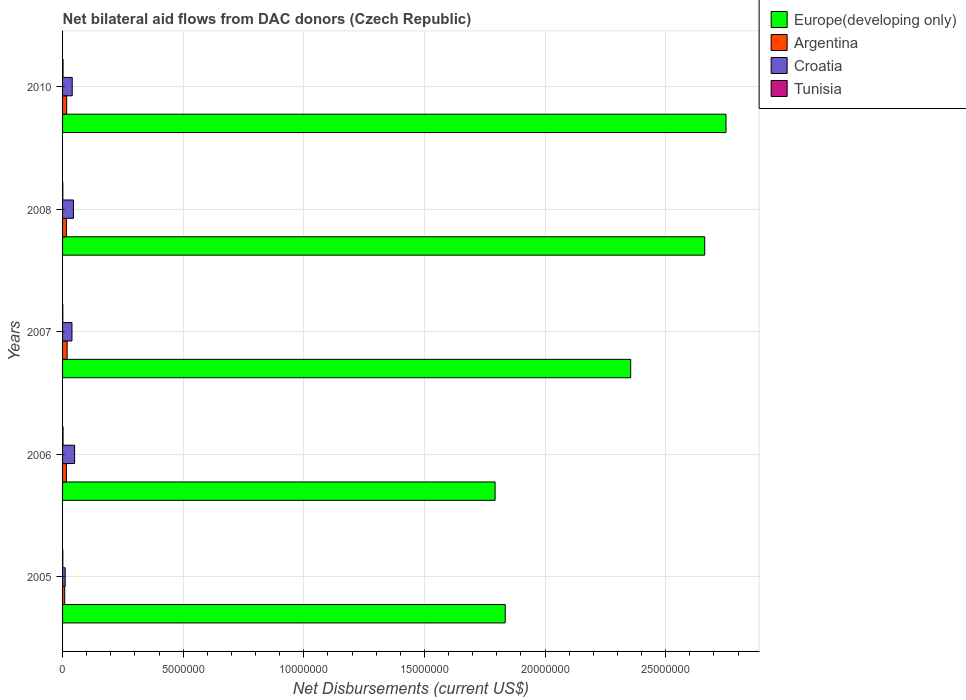How many groups of bars are there?
Your answer should be very brief. 5. Are the number of bars per tick equal to the number of legend labels?
Provide a succinct answer. Yes. Are the number of bars on each tick of the Y-axis equal?
Give a very brief answer. Yes. How many bars are there on the 4th tick from the top?
Offer a very short reply. 4. What is the label of the 1st group of bars from the top?
Keep it short and to the point. 2010. What is the net bilateral aid flows in Europe(developing only) in 2006?
Your answer should be very brief. 1.79e+07. Across all years, what is the maximum net bilateral aid flows in Europe(developing only)?
Your answer should be very brief. 2.75e+07. Across all years, what is the minimum net bilateral aid flows in Europe(developing only)?
Provide a short and direct response. 1.79e+07. In which year was the net bilateral aid flows in Europe(developing only) maximum?
Offer a terse response. 2010. What is the total net bilateral aid flows in Argentina in the graph?
Make the answer very short. 7.70e+05. What is the difference between the net bilateral aid flows in Europe(developing only) in 2006 and that in 2010?
Make the answer very short. -9.57e+06. What is the average net bilateral aid flows in Argentina per year?
Offer a terse response. 1.54e+05. In the year 2010, what is the difference between the net bilateral aid flows in Europe(developing only) and net bilateral aid flows in Tunisia?
Your response must be concise. 2.75e+07. What is the ratio of the net bilateral aid flows in Europe(developing only) in 2007 to that in 2008?
Give a very brief answer. 0.88. What is the difference between the highest and the second highest net bilateral aid flows in Croatia?
Your answer should be compact. 5.00e+04. What is the difference between the highest and the lowest net bilateral aid flows in Tunisia?
Offer a very short reply. 10000. In how many years, is the net bilateral aid flows in Europe(developing only) greater than the average net bilateral aid flows in Europe(developing only) taken over all years?
Your answer should be very brief. 3. Is the sum of the net bilateral aid flows in Argentina in 2005 and 2006 greater than the maximum net bilateral aid flows in Tunisia across all years?
Provide a succinct answer. Yes. What does the 1st bar from the bottom in 2010 represents?
Give a very brief answer. Europe(developing only). How many bars are there?
Your answer should be compact. 20. Are all the bars in the graph horizontal?
Make the answer very short. Yes. What is the difference between two consecutive major ticks on the X-axis?
Provide a succinct answer. 5.00e+06. Does the graph contain any zero values?
Your answer should be very brief. No. Does the graph contain grids?
Keep it short and to the point. Yes. Where does the legend appear in the graph?
Offer a very short reply. Top right. How many legend labels are there?
Keep it short and to the point. 4. What is the title of the graph?
Make the answer very short. Net bilateral aid flows from DAC donors (Czech Republic). What is the label or title of the X-axis?
Offer a terse response. Net Disbursements (current US$). What is the label or title of the Y-axis?
Provide a succinct answer. Years. What is the Net Disbursements (current US$) of Europe(developing only) in 2005?
Offer a terse response. 1.84e+07. What is the Net Disbursements (current US$) in Argentina in 2005?
Give a very brief answer. 9.00e+04. What is the Net Disbursements (current US$) of Tunisia in 2005?
Provide a short and direct response. 10000. What is the Net Disbursements (current US$) in Europe(developing only) in 2006?
Your answer should be compact. 1.79e+07. What is the Net Disbursements (current US$) of Tunisia in 2006?
Ensure brevity in your answer.  2.00e+04. What is the Net Disbursements (current US$) in Europe(developing only) in 2007?
Provide a succinct answer. 2.36e+07. What is the Net Disbursements (current US$) of Tunisia in 2007?
Provide a succinct answer. 10000. What is the Net Disbursements (current US$) of Europe(developing only) in 2008?
Your response must be concise. 2.66e+07. What is the Net Disbursements (current US$) of Croatia in 2008?
Your response must be concise. 4.50e+05. What is the Net Disbursements (current US$) of Tunisia in 2008?
Ensure brevity in your answer.  10000. What is the Net Disbursements (current US$) in Europe(developing only) in 2010?
Offer a very short reply. 2.75e+07. What is the Net Disbursements (current US$) in Tunisia in 2010?
Give a very brief answer. 2.00e+04. Across all years, what is the maximum Net Disbursements (current US$) in Europe(developing only)?
Your answer should be compact. 2.75e+07. Across all years, what is the maximum Net Disbursements (current US$) of Argentina?
Offer a very short reply. 1.90e+05. Across all years, what is the minimum Net Disbursements (current US$) in Europe(developing only)?
Offer a terse response. 1.79e+07. Across all years, what is the minimum Net Disbursements (current US$) of Croatia?
Provide a short and direct response. 1.10e+05. Across all years, what is the minimum Net Disbursements (current US$) in Tunisia?
Give a very brief answer. 10000. What is the total Net Disbursements (current US$) of Europe(developing only) in the graph?
Your answer should be very brief. 1.14e+08. What is the total Net Disbursements (current US$) of Argentina in the graph?
Offer a very short reply. 7.70e+05. What is the total Net Disbursements (current US$) of Croatia in the graph?
Provide a succinct answer. 1.85e+06. What is the total Net Disbursements (current US$) of Tunisia in the graph?
Ensure brevity in your answer.  7.00e+04. What is the difference between the Net Disbursements (current US$) in Croatia in 2005 and that in 2006?
Keep it short and to the point. -3.90e+05. What is the difference between the Net Disbursements (current US$) in Tunisia in 2005 and that in 2006?
Provide a short and direct response. -10000. What is the difference between the Net Disbursements (current US$) in Europe(developing only) in 2005 and that in 2007?
Offer a very short reply. -5.20e+06. What is the difference between the Net Disbursements (current US$) of Argentina in 2005 and that in 2007?
Give a very brief answer. -1.00e+05. What is the difference between the Net Disbursements (current US$) of Croatia in 2005 and that in 2007?
Offer a very short reply. -2.80e+05. What is the difference between the Net Disbursements (current US$) of Tunisia in 2005 and that in 2007?
Provide a short and direct response. 0. What is the difference between the Net Disbursements (current US$) in Europe(developing only) in 2005 and that in 2008?
Give a very brief answer. -8.27e+06. What is the difference between the Net Disbursements (current US$) of Europe(developing only) in 2005 and that in 2010?
Offer a very short reply. -9.15e+06. What is the difference between the Net Disbursements (current US$) of Argentina in 2005 and that in 2010?
Give a very brief answer. -8.00e+04. What is the difference between the Net Disbursements (current US$) of Tunisia in 2005 and that in 2010?
Offer a terse response. -10000. What is the difference between the Net Disbursements (current US$) in Europe(developing only) in 2006 and that in 2007?
Give a very brief answer. -5.62e+06. What is the difference between the Net Disbursements (current US$) of Europe(developing only) in 2006 and that in 2008?
Provide a succinct answer. -8.69e+06. What is the difference between the Net Disbursements (current US$) in Argentina in 2006 and that in 2008?
Offer a very short reply. 0. What is the difference between the Net Disbursements (current US$) in Croatia in 2006 and that in 2008?
Your answer should be very brief. 5.00e+04. What is the difference between the Net Disbursements (current US$) in Tunisia in 2006 and that in 2008?
Make the answer very short. 10000. What is the difference between the Net Disbursements (current US$) in Europe(developing only) in 2006 and that in 2010?
Make the answer very short. -9.57e+06. What is the difference between the Net Disbursements (current US$) in Croatia in 2006 and that in 2010?
Provide a short and direct response. 1.00e+05. What is the difference between the Net Disbursements (current US$) in Tunisia in 2006 and that in 2010?
Offer a very short reply. 0. What is the difference between the Net Disbursements (current US$) of Europe(developing only) in 2007 and that in 2008?
Offer a terse response. -3.07e+06. What is the difference between the Net Disbursements (current US$) of Croatia in 2007 and that in 2008?
Ensure brevity in your answer.  -6.00e+04. What is the difference between the Net Disbursements (current US$) of Europe(developing only) in 2007 and that in 2010?
Make the answer very short. -3.95e+06. What is the difference between the Net Disbursements (current US$) of Croatia in 2007 and that in 2010?
Keep it short and to the point. -10000. What is the difference between the Net Disbursements (current US$) in Tunisia in 2007 and that in 2010?
Make the answer very short. -10000. What is the difference between the Net Disbursements (current US$) of Europe(developing only) in 2008 and that in 2010?
Make the answer very short. -8.80e+05. What is the difference between the Net Disbursements (current US$) of Argentina in 2008 and that in 2010?
Provide a short and direct response. -10000. What is the difference between the Net Disbursements (current US$) in Europe(developing only) in 2005 and the Net Disbursements (current US$) in Argentina in 2006?
Offer a very short reply. 1.82e+07. What is the difference between the Net Disbursements (current US$) in Europe(developing only) in 2005 and the Net Disbursements (current US$) in Croatia in 2006?
Your answer should be compact. 1.78e+07. What is the difference between the Net Disbursements (current US$) of Europe(developing only) in 2005 and the Net Disbursements (current US$) of Tunisia in 2006?
Make the answer very short. 1.83e+07. What is the difference between the Net Disbursements (current US$) in Argentina in 2005 and the Net Disbursements (current US$) in Croatia in 2006?
Provide a succinct answer. -4.10e+05. What is the difference between the Net Disbursements (current US$) of Argentina in 2005 and the Net Disbursements (current US$) of Tunisia in 2006?
Your response must be concise. 7.00e+04. What is the difference between the Net Disbursements (current US$) in Croatia in 2005 and the Net Disbursements (current US$) in Tunisia in 2006?
Your answer should be very brief. 9.00e+04. What is the difference between the Net Disbursements (current US$) in Europe(developing only) in 2005 and the Net Disbursements (current US$) in Argentina in 2007?
Your answer should be very brief. 1.82e+07. What is the difference between the Net Disbursements (current US$) of Europe(developing only) in 2005 and the Net Disbursements (current US$) of Croatia in 2007?
Offer a terse response. 1.80e+07. What is the difference between the Net Disbursements (current US$) of Europe(developing only) in 2005 and the Net Disbursements (current US$) of Tunisia in 2007?
Ensure brevity in your answer.  1.83e+07. What is the difference between the Net Disbursements (current US$) of Argentina in 2005 and the Net Disbursements (current US$) of Tunisia in 2007?
Ensure brevity in your answer.  8.00e+04. What is the difference between the Net Disbursements (current US$) of Europe(developing only) in 2005 and the Net Disbursements (current US$) of Argentina in 2008?
Offer a terse response. 1.82e+07. What is the difference between the Net Disbursements (current US$) in Europe(developing only) in 2005 and the Net Disbursements (current US$) in Croatia in 2008?
Your answer should be very brief. 1.79e+07. What is the difference between the Net Disbursements (current US$) in Europe(developing only) in 2005 and the Net Disbursements (current US$) in Tunisia in 2008?
Provide a succinct answer. 1.83e+07. What is the difference between the Net Disbursements (current US$) in Argentina in 2005 and the Net Disbursements (current US$) in Croatia in 2008?
Provide a succinct answer. -3.60e+05. What is the difference between the Net Disbursements (current US$) in Argentina in 2005 and the Net Disbursements (current US$) in Tunisia in 2008?
Offer a very short reply. 8.00e+04. What is the difference between the Net Disbursements (current US$) in Europe(developing only) in 2005 and the Net Disbursements (current US$) in Argentina in 2010?
Keep it short and to the point. 1.82e+07. What is the difference between the Net Disbursements (current US$) in Europe(developing only) in 2005 and the Net Disbursements (current US$) in Croatia in 2010?
Make the answer very short. 1.80e+07. What is the difference between the Net Disbursements (current US$) in Europe(developing only) in 2005 and the Net Disbursements (current US$) in Tunisia in 2010?
Provide a short and direct response. 1.83e+07. What is the difference between the Net Disbursements (current US$) in Argentina in 2005 and the Net Disbursements (current US$) in Croatia in 2010?
Offer a very short reply. -3.10e+05. What is the difference between the Net Disbursements (current US$) in Argentina in 2005 and the Net Disbursements (current US$) in Tunisia in 2010?
Your response must be concise. 7.00e+04. What is the difference between the Net Disbursements (current US$) in Croatia in 2005 and the Net Disbursements (current US$) in Tunisia in 2010?
Give a very brief answer. 9.00e+04. What is the difference between the Net Disbursements (current US$) in Europe(developing only) in 2006 and the Net Disbursements (current US$) in Argentina in 2007?
Ensure brevity in your answer.  1.77e+07. What is the difference between the Net Disbursements (current US$) in Europe(developing only) in 2006 and the Net Disbursements (current US$) in Croatia in 2007?
Your answer should be compact. 1.75e+07. What is the difference between the Net Disbursements (current US$) in Europe(developing only) in 2006 and the Net Disbursements (current US$) in Tunisia in 2007?
Give a very brief answer. 1.79e+07. What is the difference between the Net Disbursements (current US$) in Croatia in 2006 and the Net Disbursements (current US$) in Tunisia in 2007?
Your answer should be compact. 4.90e+05. What is the difference between the Net Disbursements (current US$) in Europe(developing only) in 2006 and the Net Disbursements (current US$) in Argentina in 2008?
Your response must be concise. 1.78e+07. What is the difference between the Net Disbursements (current US$) of Europe(developing only) in 2006 and the Net Disbursements (current US$) of Croatia in 2008?
Ensure brevity in your answer.  1.75e+07. What is the difference between the Net Disbursements (current US$) in Europe(developing only) in 2006 and the Net Disbursements (current US$) in Tunisia in 2008?
Offer a terse response. 1.79e+07. What is the difference between the Net Disbursements (current US$) of Europe(developing only) in 2006 and the Net Disbursements (current US$) of Argentina in 2010?
Ensure brevity in your answer.  1.78e+07. What is the difference between the Net Disbursements (current US$) of Europe(developing only) in 2006 and the Net Disbursements (current US$) of Croatia in 2010?
Your answer should be compact. 1.75e+07. What is the difference between the Net Disbursements (current US$) in Europe(developing only) in 2006 and the Net Disbursements (current US$) in Tunisia in 2010?
Give a very brief answer. 1.79e+07. What is the difference between the Net Disbursements (current US$) in Argentina in 2006 and the Net Disbursements (current US$) in Croatia in 2010?
Your answer should be very brief. -2.40e+05. What is the difference between the Net Disbursements (current US$) of Argentina in 2006 and the Net Disbursements (current US$) of Tunisia in 2010?
Make the answer very short. 1.40e+05. What is the difference between the Net Disbursements (current US$) of Europe(developing only) in 2007 and the Net Disbursements (current US$) of Argentina in 2008?
Your answer should be compact. 2.34e+07. What is the difference between the Net Disbursements (current US$) of Europe(developing only) in 2007 and the Net Disbursements (current US$) of Croatia in 2008?
Give a very brief answer. 2.31e+07. What is the difference between the Net Disbursements (current US$) in Europe(developing only) in 2007 and the Net Disbursements (current US$) in Tunisia in 2008?
Make the answer very short. 2.35e+07. What is the difference between the Net Disbursements (current US$) of Croatia in 2007 and the Net Disbursements (current US$) of Tunisia in 2008?
Keep it short and to the point. 3.80e+05. What is the difference between the Net Disbursements (current US$) of Europe(developing only) in 2007 and the Net Disbursements (current US$) of Argentina in 2010?
Give a very brief answer. 2.34e+07. What is the difference between the Net Disbursements (current US$) of Europe(developing only) in 2007 and the Net Disbursements (current US$) of Croatia in 2010?
Provide a succinct answer. 2.32e+07. What is the difference between the Net Disbursements (current US$) of Europe(developing only) in 2007 and the Net Disbursements (current US$) of Tunisia in 2010?
Ensure brevity in your answer.  2.35e+07. What is the difference between the Net Disbursements (current US$) in Croatia in 2007 and the Net Disbursements (current US$) in Tunisia in 2010?
Offer a very short reply. 3.70e+05. What is the difference between the Net Disbursements (current US$) in Europe(developing only) in 2008 and the Net Disbursements (current US$) in Argentina in 2010?
Make the answer very short. 2.64e+07. What is the difference between the Net Disbursements (current US$) in Europe(developing only) in 2008 and the Net Disbursements (current US$) in Croatia in 2010?
Ensure brevity in your answer.  2.62e+07. What is the difference between the Net Disbursements (current US$) of Europe(developing only) in 2008 and the Net Disbursements (current US$) of Tunisia in 2010?
Provide a succinct answer. 2.66e+07. What is the average Net Disbursements (current US$) in Europe(developing only) per year?
Give a very brief answer. 2.28e+07. What is the average Net Disbursements (current US$) in Argentina per year?
Ensure brevity in your answer.  1.54e+05. What is the average Net Disbursements (current US$) of Tunisia per year?
Your response must be concise. 1.40e+04. In the year 2005, what is the difference between the Net Disbursements (current US$) in Europe(developing only) and Net Disbursements (current US$) in Argentina?
Your response must be concise. 1.83e+07. In the year 2005, what is the difference between the Net Disbursements (current US$) of Europe(developing only) and Net Disbursements (current US$) of Croatia?
Your response must be concise. 1.82e+07. In the year 2005, what is the difference between the Net Disbursements (current US$) of Europe(developing only) and Net Disbursements (current US$) of Tunisia?
Offer a very short reply. 1.83e+07. In the year 2005, what is the difference between the Net Disbursements (current US$) in Argentina and Net Disbursements (current US$) in Croatia?
Make the answer very short. -2.00e+04. In the year 2005, what is the difference between the Net Disbursements (current US$) in Croatia and Net Disbursements (current US$) in Tunisia?
Keep it short and to the point. 1.00e+05. In the year 2006, what is the difference between the Net Disbursements (current US$) in Europe(developing only) and Net Disbursements (current US$) in Argentina?
Your answer should be very brief. 1.78e+07. In the year 2006, what is the difference between the Net Disbursements (current US$) in Europe(developing only) and Net Disbursements (current US$) in Croatia?
Make the answer very short. 1.74e+07. In the year 2006, what is the difference between the Net Disbursements (current US$) in Europe(developing only) and Net Disbursements (current US$) in Tunisia?
Ensure brevity in your answer.  1.79e+07. In the year 2006, what is the difference between the Net Disbursements (current US$) in Argentina and Net Disbursements (current US$) in Croatia?
Your answer should be very brief. -3.40e+05. In the year 2006, what is the difference between the Net Disbursements (current US$) of Croatia and Net Disbursements (current US$) of Tunisia?
Make the answer very short. 4.80e+05. In the year 2007, what is the difference between the Net Disbursements (current US$) in Europe(developing only) and Net Disbursements (current US$) in Argentina?
Your response must be concise. 2.34e+07. In the year 2007, what is the difference between the Net Disbursements (current US$) of Europe(developing only) and Net Disbursements (current US$) of Croatia?
Make the answer very short. 2.32e+07. In the year 2007, what is the difference between the Net Disbursements (current US$) of Europe(developing only) and Net Disbursements (current US$) of Tunisia?
Provide a succinct answer. 2.35e+07. In the year 2008, what is the difference between the Net Disbursements (current US$) of Europe(developing only) and Net Disbursements (current US$) of Argentina?
Ensure brevity in your answer.  2.65e+07. In the year 2008, what is the difference between the Net Disbursements (current US$) of Europe(developing only) and Net Disbursements (current US$) of Croatia?
Your answer should be very brief. 2.62e+07. In the year 2008, what is the difference between the Net Disbursements (current US$) of Europe(developing only) and Net Disbursements (current US$) of Tunisia?
Give a very brief answer. 2.66e+07. In the year 2010, what is the difference between the Net Disbursements (current US$) of Europe(developing only) and Net Disbursements (current US$) of Argentina?
Your answer should be compact. 2.73e+07. In the year 2010, what is the difference between the Net Disbursements (current US$) of Europe(developing only) and Net Disbursements (current US$) of Croatia?
Your answer should be very brief. 2.71e+07. In the year 2010, what is the difference between the Net Disbursements (current US$) of Europe(developing only) and Net Disbursements (current US$) of Tunisia?
Offer a very short reply. 2.75e+07. In the year 2010, what is the difference between the Net Disbursements (current US$) in Argentina and Net Disbursements (current US$) in Croatia?
Offer a very short reply. -2.30e+05. In the year 2010, what is the difference between the Net Disbursements (current US$) of Argentina and Net Disbursements (current US$) of Tunisia?
Provide a succinct answer. 1.50e+05. What is the ratio of the Net Disbursements (current US$) in Europe(developing only) in 2005 to that in 2006?
Your answer should be compact. 1.02. What is the ratio of the Net Disbursements (current US$) of Argentina in 2005 to that in 2006?
Ensure brevity in your answer.  0.56. What is the ratio of the Net Disbursements (current US$) in Croatia in 2005 to that in 2006?
Your answer should be compact. 0.22. What is the ratio of the Net Disbursements (current US$) in Europe(developing only) in 2005 to that in 2007?
Your answer should be compact. 0.78. What is the ratio of the Net Disbursements (current US$) of Argentina in 2005 to that in 2007?
Give a very brief answer. 0.47. What is the ratio of the Net Disbursements (current US$) of Croatia in 2005 to that in 2007?
Your answer should be very brief. 0.28. What is the ratio of the Net Disbursements (current US$) in Europe(developing only) in 2005 to that in 2008?
Your response must be concise. 0.69. What is the ratio of the Net Disbursements (current US$) in Argentina in 2005 to that in 2008?
Offer a very short reply. 0.56. What is the ratio of the Net Disbursements (current US$) in Croatia in 2005 to that in 2008?
Your answer should be very brief. 0.24. What is the ratio of the Net Disbursements (current US$) of Tunisia in 2005 to that in 2008?
Keep it short and to the point. 1. What is the ratio of the Net Disbursements (current US$) in Europe(developing only) in 2005 to that in 2010?
Offer a terse response. 0.67. What is the ratio of the Net Disbursements (current US$) of Argentina in 2005 to that in 2010?
Give a very brief answer. 0.53. What is the ratio of the Net Disbursements (current US$) in Croatia in 2005 to that in 2010?
Offer a terse response. 0.28. What is the ratio of the Net Disbursements (current US$) in Tunisia in 2005 to that in 2010?
Offer a terse response. 0.5. What is the ratio of the Net Disbursements (current US$) in Europe(developing only) in 2006 to that in 2007?
Keep it short and to the point. 0.76. What is the ratio of the Net Disbursements (current US$) in Argentina in 2006 to that in 2007?
Your response must be concise. 0.84. What is the ratio of the Net Disbursements (current US$) of Croatia in 2006 to that in 2007?
Provide a short and direct response. 1.28. What is the ratio of the Net Disbursements (current US$) of Europe(developing only) in 2006 to that in 2008?
Provide a succinct answer. 0.67. What is the ratio of the Net Disbursements (current US$) of Argentina in 2006 to that in 2008?
Offer a very short reply. 1. What is the ratio of the Net Disbursements (current US$) of Tunisia in 2006 to that in 2008?
Give a very brief answer. 2. What is the ratio of the Net Disbursements (current US$) of Europe(developing only) in 2006 to that in 2010?
Your response must be concise. 0.65. What is the ratio of the Net Disbursements (current US$) in Argentina in 2006 to that in 2010?
Ensure brevity in your answer.  0.94. What is the ratio of the Net Disbursements (current US$) of Croatia in 2006 to that in 2010?
Ensure brevity in your answer.  1.25. What is the ratio of the Net Disbursements (current US$) of Tunisia in 2006 to that in 2010?
Your answer should be compact. 1. What is the ratio of the Net Disbursements (current US$) of Europe(developing only) in 2007 to that in 2008?
Provide a succinct answer. 0.88. What is the ratio of the Net Disbursements (current US$) in Argentina in 2007 to that in 2008?
Ensure brevity in your answer.  1.19. What is the ratio of the Net Disbursements (current US$) in Croatia in 2007 to that in 2008?
Offer a terse response. 0.87. What is the ratio of the Net Disbursements (current US$) of Tunisia in 2007 to that in 2008?
Provide a short and direct response. 1. What is the ratio of the Net Disbursements (current US$) of Europe(developing only) in 2007 to that in 2010?
Ensure brevity in your answer.  0.86. What is the ratio of the Net Disbursements (current US$) in Argentina in 2007 to that in 2010?
Make the answer very short. 1.12. What is the ratio of the Net Disbursements (current US$) in Tunisia in 2007 to that in 2010?
Give a very brief answer. 0.5. What is the ratio of the Net Disbursements (current US$) of Argentina in 2008 to that in 2010?
Your answer should be very brief. 0.94. What is the ratio of the Net Disbursements (current US$) in Croatia in 2008 to that in 2010?
Offer a terse response. 1.12. What is the ratio of the Net Disbursements (current US$) of Tunisia in 2008 to that in 2010?
Your response must be concise. 0.5. What is the difference between the highest and the second highest Net Disbursements (current US$) of Europe(developing only)?
Provide a short and direct response. 8.80e+05. What is the difference between the highest and the second highest Net Disbursements (current US$) in Croatia?
Ensure brevity in your answer.  5.00e+04. What is the difference between the highest and the second highest Net Disbursements (current US$) in Tunisia?
Ensure brevity in your answer.  0. What is the difference between the highest and the lowest Net Disbursements (current US$) in Europe(developing only)?
Provide a succinct answer. 9.57e+06. 